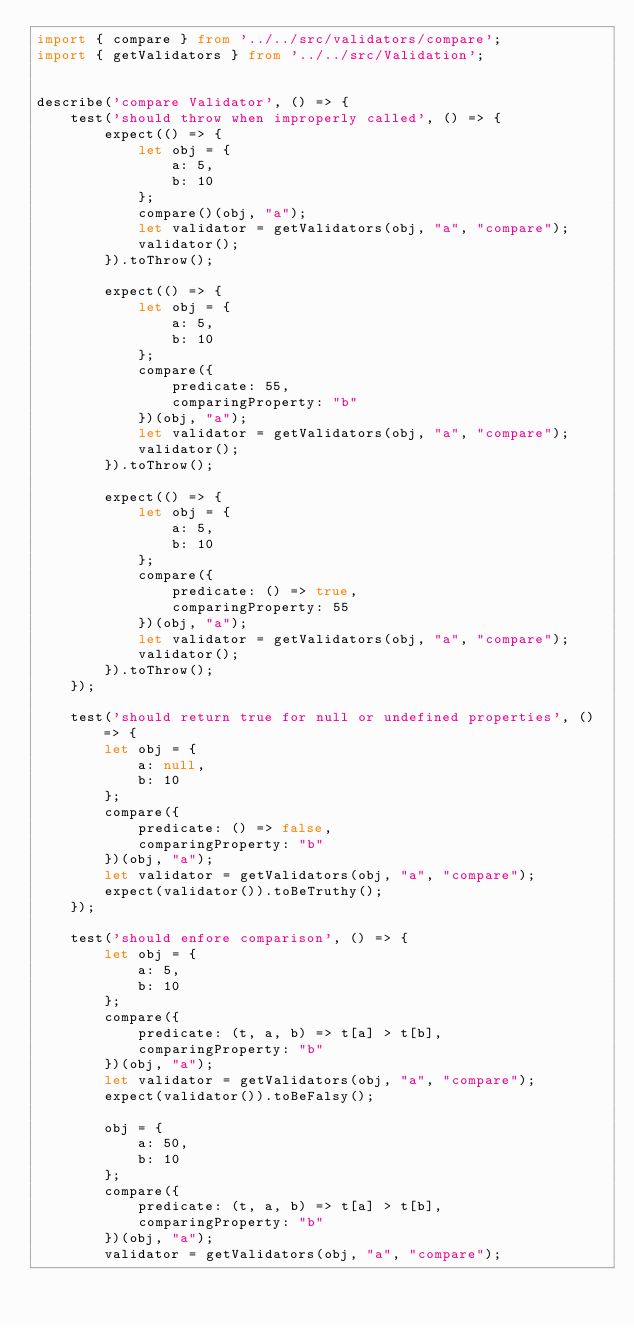<code> <loc_0><loc_0><loc_500><loc_500><_TypeScript_>import { compare } from '../../src/validators/compare';
import { getValidators } from '../../src/Validation';


describe('compare Validator', () => {
    test('should throw when improperly called', () => {
        expect(() => {
            let obj = {
                a: 5,
                b: 10
            };
            compare()(obj, "a");
            let validator = getValidators(obj, "a", "compare");
            validator();
        }).toThrow();

        expect(() => {
            let obj = {
                a: 5,
                b: 10
            };
            compare({
                predicate: 55,
                comparingProperty: "b"
            })(obj, "a");
            let validator = getValidators(obj, "a", "compare");
            validator();
        }).toThrow();

        expect(() => {
            let obj = {
                a: 5,
                b: 10
            };
            compare({
                predicate: () => true,
                comparingProperty: 55
            })(obj, "a");
            let validator = getValidators(obj, "a", "compare");
            validator();
        }).toThrow();
    });

    test('should return true for null or undefined properties', () => {
        let obj = {
            a: null,
            b: 10
        };
        compare({
            predicate: () => false,
            comparingProperty: "b"
        })(obj, "a");
        let validator = getValidators(obj, "a", "compare");
        expect(validator()).toBeTruthy();
    });

    test('should enfore comparison', () => {
        let obj = {
            a: 5,
            b: 10
        };
        compare({
            predicate: (t, a, b) => t[a] > t[b],
            comparingProperty: "b"
        })(obj, "a");
        let validator = getValidators(obj, "a", "compare");
        expect(validator()).toBeFalsy();

        obj = {
            a: 50,
            b: 10
        };
        compare({
            predicate: (t, a, b) => t[a] > t[b],
            comparingProperty: "b"
        })(obj, "a");
        validator = getValidators(obj, "a", "compare");</code> 